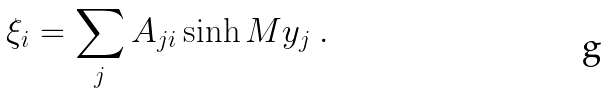<formula> <loc_0><loc_0><loc_500><loc_500>\xi _ { i } = \sum _ { j } A _ { j i } \sinh M y _ { j } \ .</formula> 